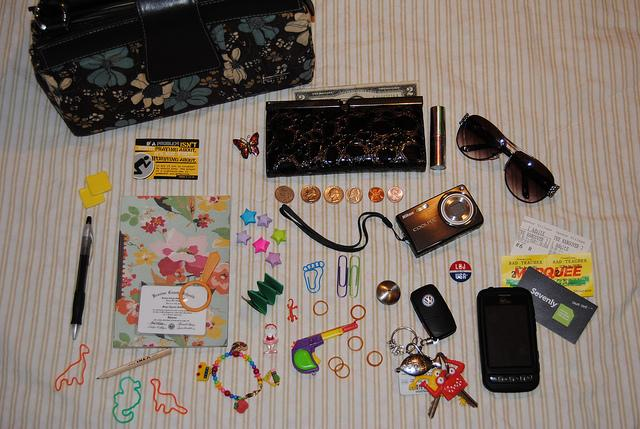What brand of car does this person drive? Please explain your reasoning. volkswagen. The key fob for the car has a vw logo on it. 